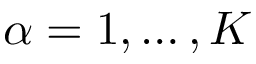<formula> <loc_0><loc_0><loc_500><loc_500>{ \alpha = 1 , \dots , K }</formula> 